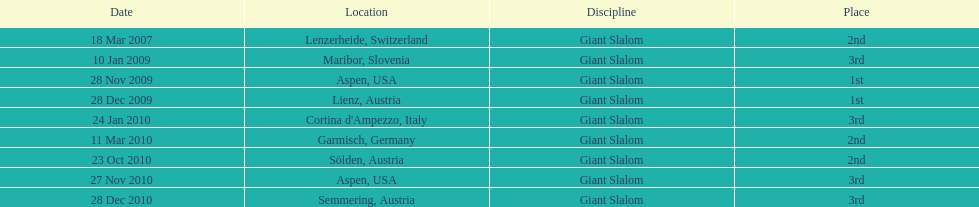Where was her first win? Aspen, USA. 